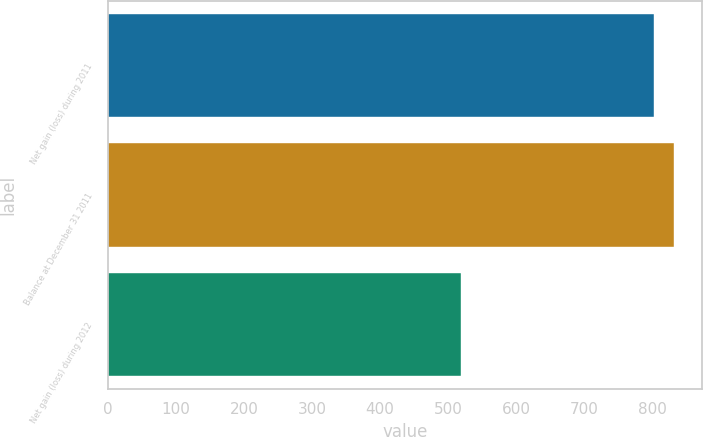Convert chart. <chart><loc_0><loc_0><loc_500><loc_500><bar_chart><fcel>Net gain (loss) during 2011<fcel>Balance at December 31 2011<fcel>Net gain (loss) during 2012<nl><fcel>803<fcel>831.4<fcel>519<nl></chart> 